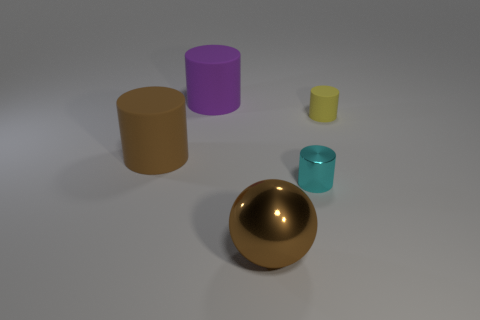Subtract 3 cylinders. How many cylinders are left? 1 Subtract all small rubber cylinders. How many cylinders are left? 3 Subtract 1 purple cylinders. How many objects are left? 4 Subtract all cylinders. How many objects are left? 1 Subtract all cyan cylinders. Subtract all yellow balls. How many cylinders are left? 3 Subtract all blue cubes. How many brown cylinders are left? 1 Subtract all big spheres. Subtract all tiny yellow rubber cylinders. How many objects are left? 3 Add 5 large brown metal objects. How many large brown metal objects are left? 6 Add 3 large purple rubber blocks. How many large purple rubber blocks exist? 3 Add 1 tiny blue shiny things. How many objects exist? 6 